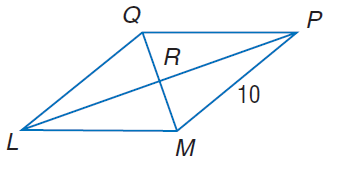Answer the mathemtical geometry problem and directly provide the correct option letter.
Question: In rhombus L M P Q, m \angle Q L M = 2 x^ { 2 } - 10, m \angle Q P M = 8 x, and M P = 10. Find Q L.
Choices: A: 10 B: 20 C: 30 D: 45 A 